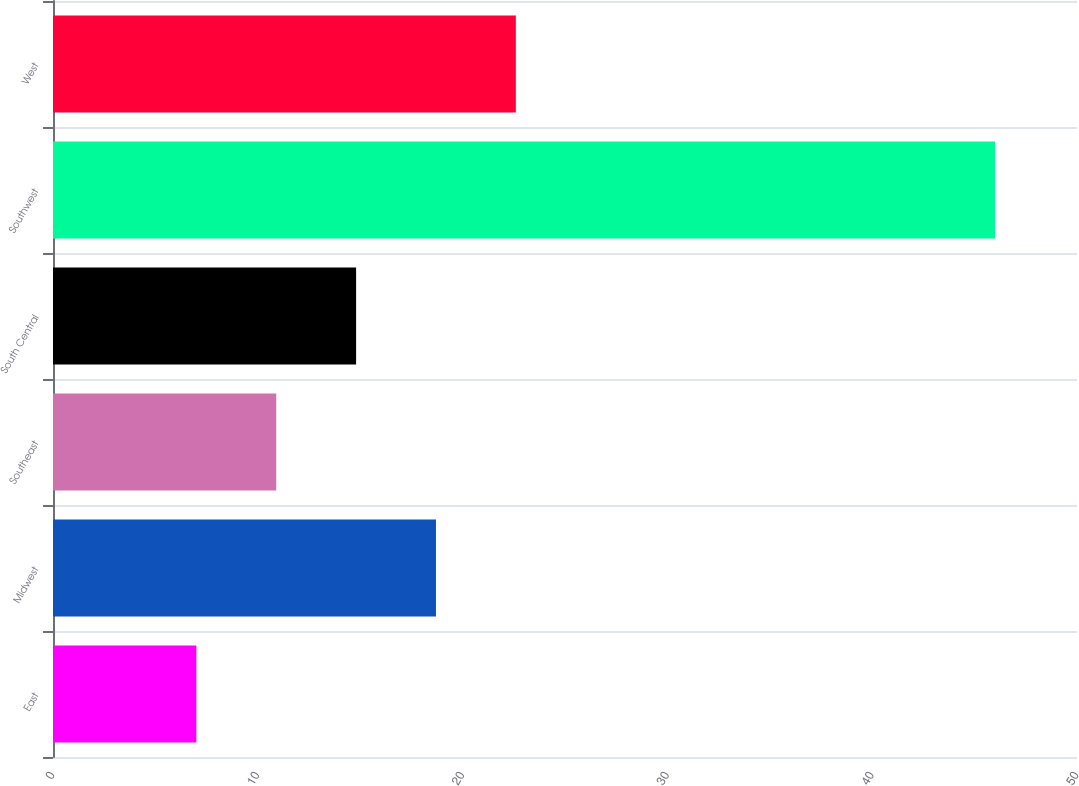<chart> <loc_0><loc_0><loc_500><loc_500><bar_chart><fcel>East<fcel>Midwest<fcel>Southeast<fcel>South Central<fcel>Southwest<fcel>West<nl><fcel>7<fcel>18.7<fcel>10.9<fcel>14.8<fcel>46<fcel>22.6<nl></chart> 